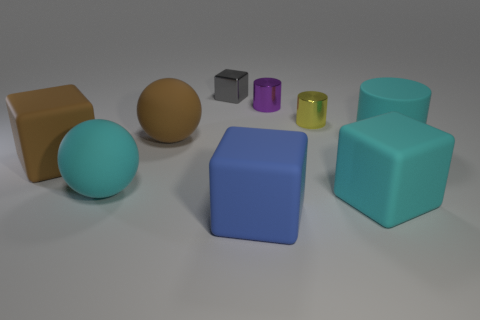Subtract all tiny shiny cylinders. How many cylinders are left? 1 Subtract all cyan spheres. How many spheres are left? 1 Subtract all cylinders. How many objects are left? 6 Subtract 1 cubes. How many cubes are left? 3 Subtract all cyan cylinders. Subtract all blue cubes. How many cylinders are left? 2 Subtract all tiny cylinders. Subtract all cyan matte things. How many objects are left? 4 Add 7 big brown cubes. How many big brown cubes are left? 8 Add 3 tiny purple balls. How many tiny purple balls exist? 3 Subtract 0 red cylinders. How many objects are left? 9 